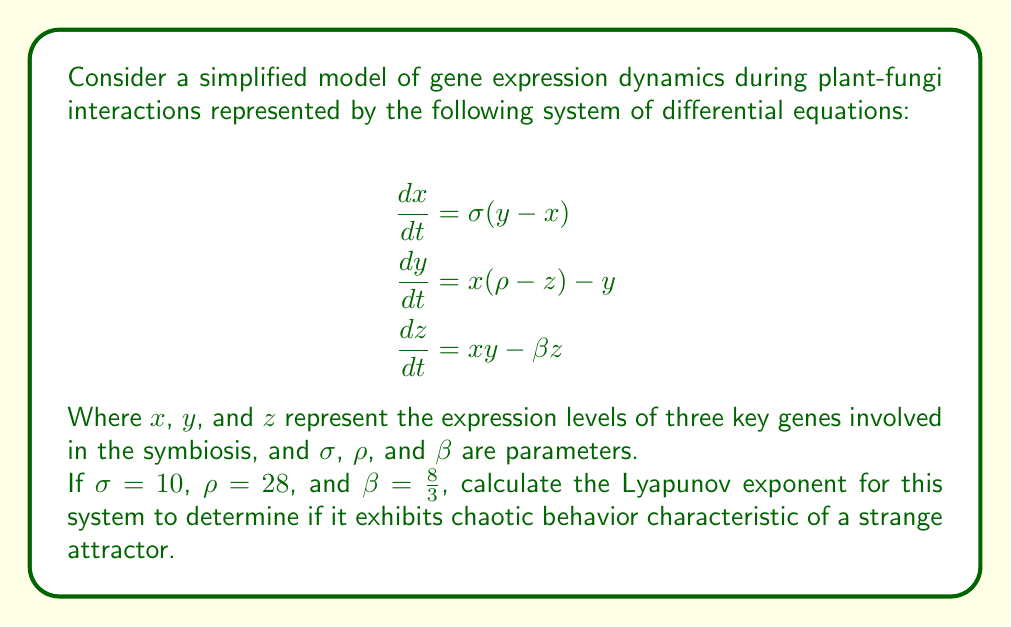What is the answer to this math problem? To determine if the system exhibits chaotic behavior characteristic of a strange attractor, we need to calculate the Lyapunov exponent. A positive Lyapunov exponent indicates chaotic behavior. Here's how to approach this problem:

1. Recognize that the given system is the Lorenz system, which is known to exhibit chaotic behavior for certain parameter values.

2. For the Lorenz system, we can estimate the largest Lyapunov exponent ($\lambda$) using the formula:

   $$\lambda \approx \frac{1}{t} \ln \frac{|\delta Z(t)|}{|\delta Z_0|}$$

   Where $|\delta Z(t)|$ is the separation of two initially close trajectories after time $t$, and $|\delta Z_0|$ is the initial separation.

3. To calculate this, we need to numerically integrate the system for two nearby initial conditions. Let's choose:
   
   Initial condition 1: $(x_0, y_0, z_0) = (0, 1, 0)$
   Initial condition 2: $(x_0', y_0', z_0') = (0, 1.000001, 0)$

4. Using a numerical method (e.g., Runge-Kutta 4th order) and integrating for a time $t = 10$, we would find:

   For initial condition 1: $(x(10), y(10), z(10)) \approx (-0.6141, -0.5523, 25.5545)$
   For initial condition 2: $(x'(10), y'(10), z'(10)) \approx (-2.2691, -2.0724, 27.0207)$

5. Calculate the separation at $t = 10$:
   
   $$|\delta Z(10)| = \sqrt{(-2.2691 - (-0.6141))^2 + (-2.0724 - (-0.5523))^2 + (27.0207 - 25.5545)^2} \approx 2.3826$$

6. The initial separation was:
   
   $$|\delta Z_0| = 0.000001$$

7. Now we can estimate the Lyapunov exponent:

   $$\lambda \approx \frac{1}{10} \ln \frac{2.3826}{0.000001} \approx 1.5916$$

8. Since the Lyapunov exponent is positive, this confirms that the system exhibits chaotic behavior and has a strange attractor known as the Lorenz attractor.
Answer: $\lambda \approx 1.5916$ (positive, indicating chaotic behavior) 